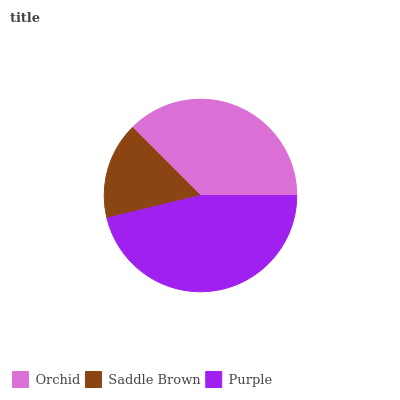Is Saddle Brown the minimum?
Answer yes or no. Yes. Is Purple the maximum?
Answer yes or no. Yes. Is Purple the minimum?
Answer yes or no. No. Is Saddle Brown the maximum?
Answer yes or no. No. Is Purple greater than Saddle Brown?
Answer yes or no. Yes. Is Saddle Brown less than Purple?
Answer yes or no. Yes. Is Saddle Brown greater than Purple?
Answer yes or no. No. Is Purple less than Saddle Brown?
Answer yes or no. No. Is Orchid the high median?
Answer yes or no. Yes. Is Orchid the low median?
Answer yes or no. Yes. Is Purple the high median?
Answer yes or no. No. Is Purple the low median?
Answer yes or no. No. 